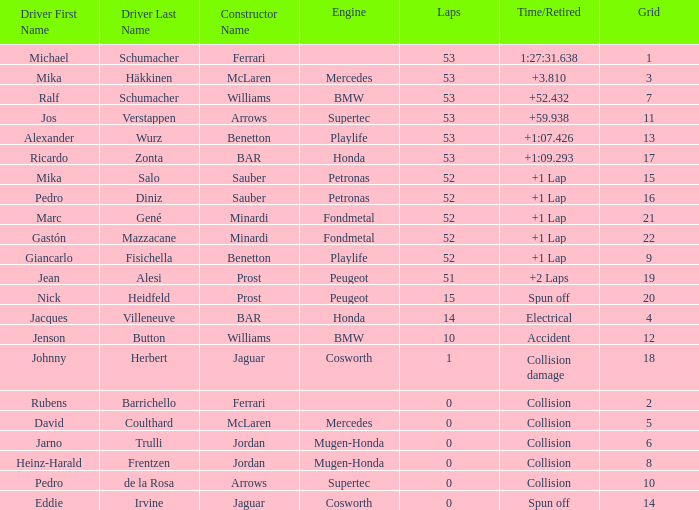How many circuits did ricardo zonta complete? 53.0. 